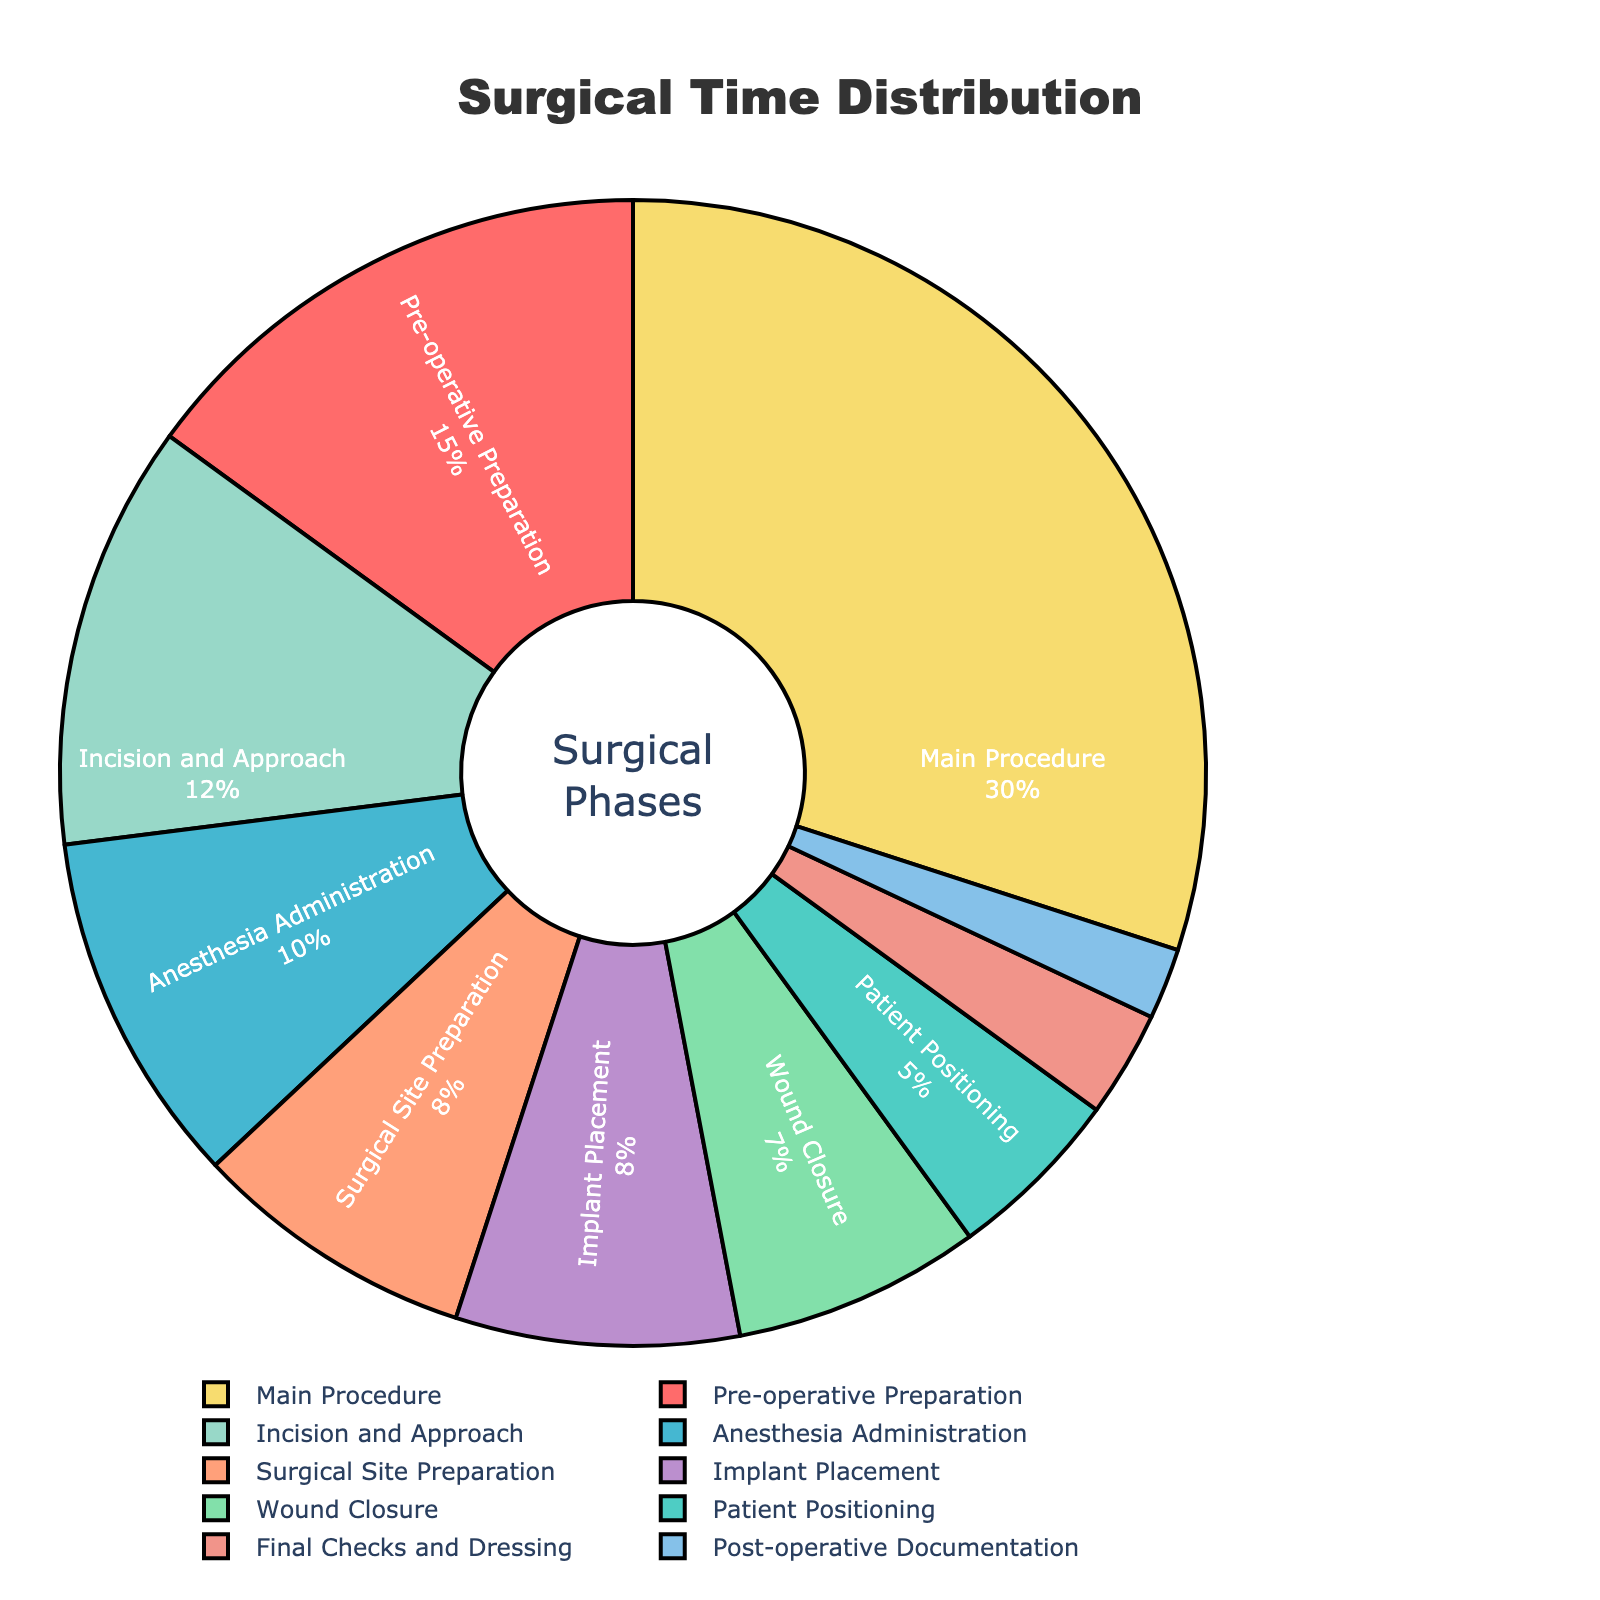What's the percentage of time spent on the main procedure? To find the time spent on the main procedure, simply look at the segment labeled "Main Procedure" in the pie chart.
Answer: 30% What is the combined percentage for the phases "Incision and Approach" and "Wound Closure"? Add the percentages for "Incision and Approach" (12%) and "Wound Closure" (7%). 12 + 7 = 19
Answer: 19% Which phase takes up more time: "Patient Positioning" or "Final Checks and Dressing"? Compare the percentages: "Patient Positioning" is 5%, and "Final Checks and Dressing" is 3%. 5% > 3%
Answer: Patient Positioning What is the total percentage spent on non-procedure phases (all phases except "Main Procedure")? Add the percentages of all phases except "Main Procedure": 15 + 5 + 10 + 8 + 12 + 8 + 7 + 3 + 2. Total = 70
Answer: 70% What proportion of the surgical time is devoted to anesthesia-related activities ("Anesthesia Administration" and "Surgical Site Preparation") relative to the total? Combine the percentages of "Anesthesia Administration" (10%) and "Surgical Site Preparation" (8%), then divide by the total (100%). (10 + 8) / 100 = 18%
Answer: 18% Which phase has the smallest percentage of surgical time, and what is its color in the chart? The smallest percentage is found in the phase "Post-operative Documentation" which is 2%. According to the provided colors, it should be the last color in the list, which is light blue (#85C1E9).
Answer: Post-operative Documentation, light blue How much more time is spent on "Pre-operative Preparation" compared to "Implant Placement"? Subtract the percentage of "Implant Placement" (8%) from "Pre-operative Preparation" (15%). 15 - 8 = 7
Answer: 7% Which three phases together occupy exactly half of the total surgical time? Identify the phases whose combined total is 50%. The phases "Main Procedure" (30%), "Pre-operative Preparation" (15%), and "Anesthesia Administration" (10%) give us a total of 30 + 15 + 10 = 55. So instead we should consider "Main Procedure" (30%), "Incision and Approach" (12%), and "Pre-operative Preparation" (15%), totalling 30 + 12 + 8 = 50.
Answer: Main Procedure, Incision and Approach, Pre-operative Preparation 